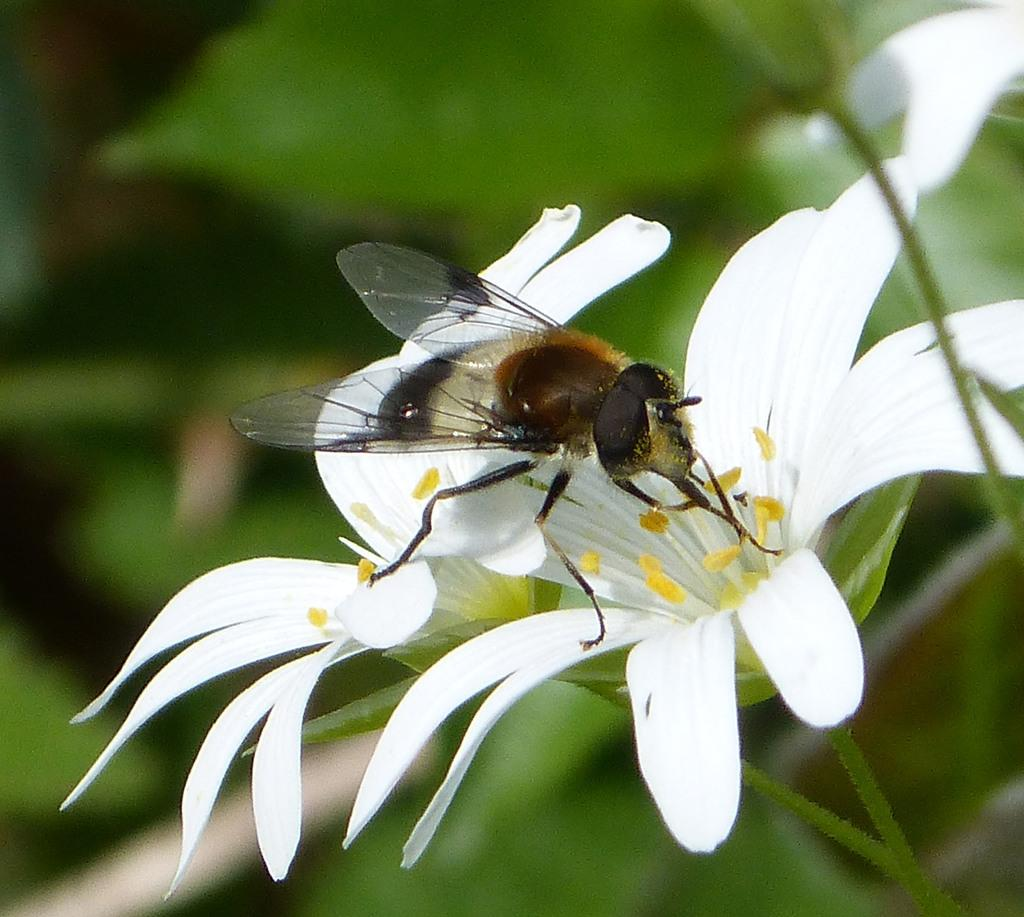What type of living organisms can be seen in the picture? There are flowers in the picture. Are there any insects present in the image? Yes, there is a fly on one of the flowers. How many women are sitting on the bed in the image? There is no bed or women present in the image; it features flowers and a fly. What type of ornament is hanging from the flower in the image? There is no ornament present on the flower in the image; it only features a fly. 